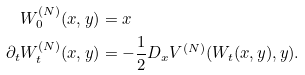<formula> <loc_0><loc_0><loc_500><loc_500>W _ { 0 } ^ { ( N ) } ( x , y ) & = x \\ \partial _ { t } W _ { t } ^ { ( N ) } ( x , y ) & = - \frac { 1 } { 2 } D _ { x } V ^ { ( N ) } ( W _ { t } ( x , y ) , y ) .</formula> 